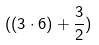Convert formula to latex. <formula><loc_0><loc_0><loc_500><loc_500>( ( 3 \cdot 6 ) + \frac { 3 } { 2 } )</formula> 